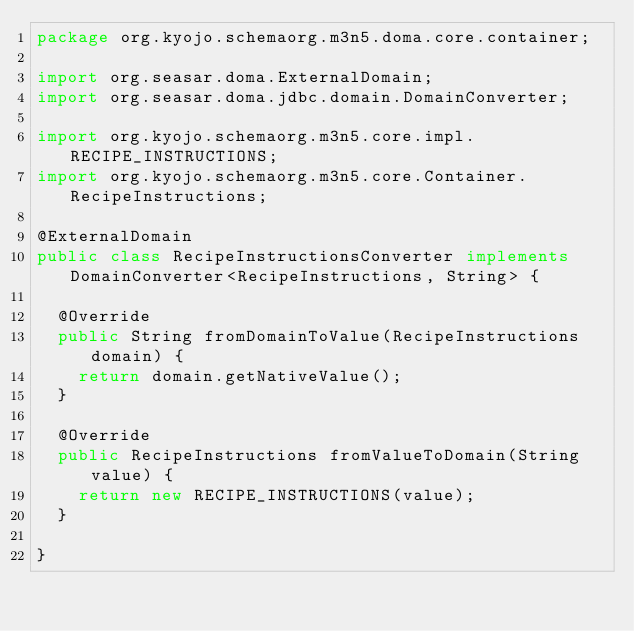Convert code to text. <code><loc_0><loc_0><loc_500><loc_500><_Java_>package org.kyojo.schemaorg.m3n5.doma.core.container;

import org.seasar.doma.ExternalDomain;
import org.seasar.doma.jdbc.domain.DomainConverter;

import org.kyojo.schemaorg.m3n5.core.impl.RECIPE_INSTRUCTIONS;
import org.kyojo.schemaorg.m3n5.core.Container.RecipeInstructions;

@ExternalDomain
public class RecipeInstructionsConverter implements DomainConverter<RecipeInstructions, String> {

	@Override
	public String fromDomainToValue(RecipeInstructions domain) {
		return domain.getNativeValue();
	}

	@Override
	public RecipeInstructions fromValueToDomain(String value) {
		return new RECIPE_INSTRUCTIONS(value);
	}

}
</code> 